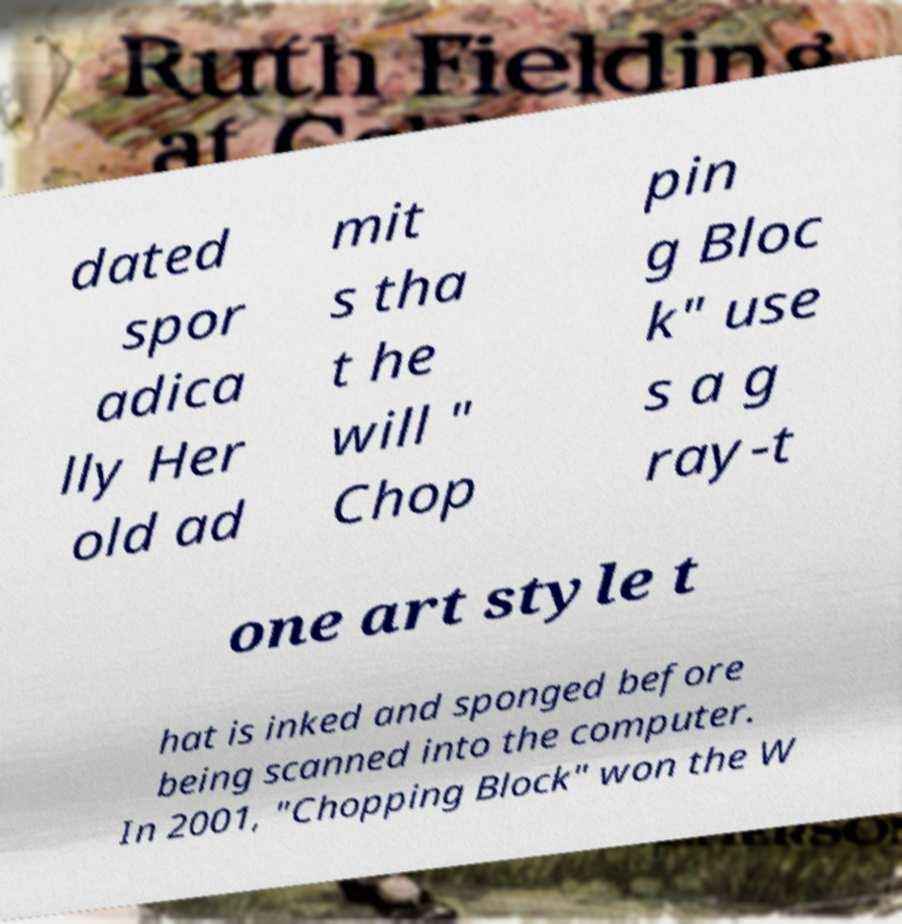Can you accurately transcribe the text from the provided image for me? dated spor adica lly Her old ad mit s tha t he will " Chop pin g Bloc k" use s a g ray-t one art style t hat is inked and sponged before being scanned into the computer. In 2001, "Chopping Block" won the W 